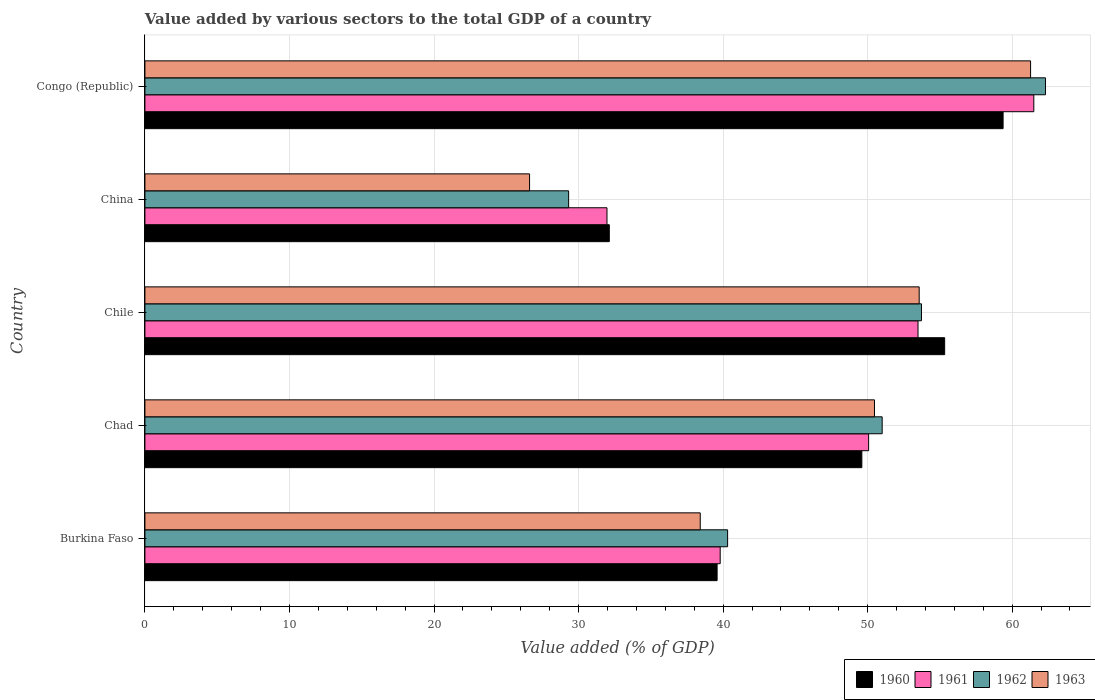How many different coloured bars are there?
Provide a short and direct response. 4. Are the number of bars per tick equal to the number of legend labels?
Give a very brief answer. Yes. Are the number of bars on each tick of the Y-axis equal?
Your answer should be very brief. Yes. What is the label of the 1st group of bars from the top?
Keep it short and to the point. Congo (Republic). In how many cases, is the number of bars for a given country not equal to the number of legend labels?
Provide a short and direct response. 0. What is the value added by various sectors to the total GDP in 1961 in Congo (Republic)?
Keep it short and to the point. 61.5. Across all countries, what is the maximum value added by various sectors to the total GDP in 1961?
Your response must be concise. 61.5. Across all countries, what is the minimum value added by various sectors to the total GDP in 1962?
Your answer should be very brief. 29.31. In which country was the value added by various sectors to the total GDP in 1963 maximum?
Your answer should be very brief. Congo (Republic). In which country was the value added by various sectors to the total GDP in 1961 minimum?
Keep it short and to the point. China. What is the total value added by various sectors to the total GDP in 1962 in the graph?
Make the answer very short. 236.66. What is the difference between the value added by various sectors to the total GDP in 1960 in China and that in Congo (Republic)?
Provide a succinct answer. -27.24. What is the difference between the value added by various sectors to the total GDP in 1960 in Chad and the value added by various sectors to the total GDP in 1961 in Congo (Republic)?
Your answer should be compact. -11.9. What is the average value added by various sectors to the total GDP in 1963 per country?
Your response must be concise. 46.07. What is the difference between the value added by various sectors to the total GDP in 1962 and value added by various sectors to the total GDP in 1960 in China?
Your answer should be compact. -2.81. What is the ratio of the value added by various sectors to the total GDP in 1962 in Chad to that in China?
Your answer should be very brief. 1.74. Is the difference between the value added by various sectors to the total GDP in 1962 in Burkina Faso and Chile greater than the difference between the value added by various sectors to the total GDP in 1960 in Burkina Faso and Chile?
Provide a succinct answer. Yes. What is the difference between the highest and the second highest value added by various sectors to the total GDP in 1961?
Ensure brevity in your answer.  8.01. What is the difference between the highest and the lowest value added by various sectors to the total GDP in 1960?
Offer a very short reply. 27.24. In how many countries, is the value added by various sectors to the total GDP in 1960 greater than the average value added by various sectors to the total GDP in 1960 taken over all countries?
Your response must be concise. 3. What does the 1st bar from the top in Burkina Faso represents?
Offer a very short reply. 1963. Is it the case that in every country, the sum of the value added by various sectors to the total GDP in 1961 and value added by various sectors to the total GDP in 1963 is greater than the value added by various sectors to the total GDP in 1960?
Ensure brevity in your answer.  Yes. Are all the bars in the graph horizontal?
Keep it short and to the point. Yes. How are the legend labels stacked?
Make the answer very short. Horizontal. What is the title of the graph?
Ensure brevity in your answer.  Value added by various sectors to the total GDP of a country. What is the label or title of the X-axis?
Your response must be concise. Value added (% of GDP). What is the label or title of the Y-axis?
Ensure brevity in your answer.  Country. What is the Value added (% of GDP) of 1960 in Burkina Faso?
Offer a very short reply. 39.59. What is the Value added (% of GDP) in 1961 in Burkina Faso?
Your answer should be compact. 39.8. What is the Value added (% of GDP) in 1962 in Burkina Faso?
Your answer should be compact. 40.31. What is the Value added (% of GDP) of 1963 in Burkina Faso?
Provide a short and direct response. 38.42. What is the Value added (% of GDP) in 1960 in Chad?
Give a very brief answer. 49.6. What is the Value added (% of GDP) of 1961 in Chad?
Make the answer very short. 50.07. What is the Value added (% of GDP) in 1962 in Chad?
Provide a short and direct response. 51.01. What is the Value added (% of GDP) in 1963 in Chad?
Offer a terse response. 50.47. What is the Value added (% of GDP) in 1960 in Chile?
Offer a very short reply. 55.33. What is the Value added (% of GDP) of 1961 in Chile?
Keep it short and to the point. 53.49. What is the Value added (% of GDP) of 1962 in Chile?
Give a very brief answer. 53.72. What is the Value added (% of GDP) in 1963 in Chile?
Provide a short and direct response. 53.57. What is the Value added (% of GDP) in 1960 in China?
Provide a succinct answer. 32.13. What is the Value added (% of GDP) of 1961 in China?
Give a very brief answer. 31.97. What is the Value added (% of GDP) of 1962 in China?
Your response must be concise. 29.31. What is the Value added (% of GDP) of 1963 in China?
Offer a terse response. 26.61. What is the Value added (% of GDP) in 1960 in Congo (Republic)?
Offer a very short reply. 59.37. What is the Value added (% of GDP) of 1961 in Congo (Republic)?
Your answer should be very brief. 61.5. What is the Value added (% of GDP) in 1962 in Congo (Republic)?
Your response must be concise. 62.3. What is the Value added (% of GDP) in 1963 in Congo (Republic)?
Keep it short and to the point. 61.27. Across all countries, what is the maximum Value added (% of GDP) of 1960?
Offer a very short reply. 59.37. Across all countries, what is the maximum Value added (% of GDP) of 1961?
Your response must be concise. 61.5. Across all countries, what is the maximum Value added (% of GDP) in 1962?
Your response must be concise. 62.3. Across all countries, what is the maximum Value added (% of GDP) of 1963?
Offer a very short reply. 61.27. Across all countries, what is the minimum Value added (% of GDP) of 1960?
Provide a succinct answer. 32.13. Across all countries, what is the minimum Value added (% of GDP) of 1961?
Your answer should be compact. 31.97. Across all countries, what is the minimum Value added (% of GDP) of 1962?
Ensure brevity in your answer.  29.31. Across all countries, what is the minimum Value added (% of GDP) in 1963?
Offer a very short reply. 26.61. What is the total Value added (% of GDP) in 1960 in the graph?
Provide a short and direct response. 236.01. What is the total Value added (% of GDP) in 1961 in the graph?
Provide a short and direct response. 236.82. What is the total Value added (% of GDP) in 1962 in the graph?
Your response must be concise. 236.66. What is the total Value added (% of GDP) of 1963 in the graph?
Ensure brevity in your answer.  230.34. What is the difference between the Value added (% of GDP) of 1960 in Burkina Faso and that in Chad?
Your answer should be compact. -10.01. What is the difference between the Value added (% of GDP) in 1961 in Burkina Faso and that in Chad?
Offer a very short reply. -10.27. What is the difference between the Value added (% of GDP) in 1962 in Burkina Faso and that in Chad?
Offer a very short reply. -10.69. What is the difference between the Value added (% of GDP) in 1963 in Burkina Faso and that in Chad?
Offer a very short reply. -12.06. What is the difference between the Value added (% of GDP) of 1960 in Burkina Faso and that in Chile?
Keep it short and to the point. -15.74. What is the difference between the Value added (% of GDP) of 1961 in Burkina Faso and that in Chile?
Ensure brevity in your answer.  -13.69. What is the difference between the Value added (% of GDP) in 1962 in Burkina Faso and that in Chile?
Offer a terse response. -13.41. What is the difference between the Value added (% of GDP) in 1963 in Burkina Faso and that in Chile?
Your answer should be very brief. -15.15. What is the difference between the Value added (% of GDP) in 1960 in Burkina Faso and that in China?
Your answer should be very brief. 7.46. What is the difference between the Value added (% of GDP) in 1961 in Burkina Faso and that in China?
Provide a short and direct response. 7.83. What is the difference between the Value added (% of GDP) in 1962 in Burkina Faso and that in China?
Your answer should be very brief. 11. What is the difference between the Value added (% of GDP) of 1963 in Burkina Faso and that in China?
Your response must be concise. 11.81. What is the difference between the Value added (% of GDP) in 1960 in Burkina Faso and that in Congo (Republic)?
Ensure brevity in your answer.  -19.79. What is the difference between the Value added (% of GDP) in 1961 in Burkina Faso and that in Congo (Republic)?
Offer a very short reply. -21.7. What is the difference between the Value added (% of GDP) in 1962 in Burkina Faso and that in Congo (Republic)?
Your answer should be compact. -21.99. What is the difference between the Value added (% of GDP) in 1963 in Burkina Faso and that in Congo (Republic)?
Give a very brief answer. -22.86. What is the difference between the Value added (% of GDP) in 1960 in Chad and that in Chile?
Your answer should be very brief. -5.73. What is the difference between the Value added (% of GDP) in 1961 in Chad and that in Chile?
Provide a short and direct response. -3.42. What is the difference between the Value added (% of GDP) in 1962 in Chad and that in Chile?
Ensure brevity in your answer.  -2.72. What is the difference between the Value added (% of GDP) of 1963 in Chad and that in Chile?
Ensure brevity in your answer.  -3.09. What is the difference between the Value added (% of GDP) in 1960 in Chad and that in China?
Your answer should be compact. 17.47. What is the difference between the Value added (% of GDP) in 1961 in Chad and that in China?
Give a very brief answer. 18.1. What is the difference between the Value added (% of GDP) in 1962 in Chad and that in China?
Offer a very short reply. 21.69. What is the difference between the Value added (% of GDP) of 1963 in Chad and that in China?
Provide a short and direct response. 23.86. What is the difference between the Value added (% of GDP) of 1960 in Chad and that in Congo (Republic)?
Provide a short and direct response. -9.77. What is the difference between the Value added (% of GDP) in 1961 in Chad and that in Congo (Republic)?
Your answer should be very brief. -11.43. What is the difference between the Value added (% of GDP) in 1962 in Chad and that in Congo (Republic)?
Make the answer very short. -11.3. What is the difference between the Value added (% of GDP) of 1963 in Chad and that in Congo (Republic)?
Ensure brevity in your answer.  -10.8. What is the difference between the Value added (% of GDP) of 1960 in Chile and that in China?
Provide a succinct answer. 23.2. What is the difference between the Value added (% of GDP) of 1961 in Chile and that in China?
Keep it short and to the point. 21.52. What is the difference between the Value added (% of GDP) of 1962 in Chile and that in China?
Ensure brevity in your answer.  24.41. What is the difference between the Value added (% of GDP) in 1963 in Chile and that in China?
Offer a terse response. 26.96. What is the difference between the Value added (% of GDP) of 1960 in Chile and that in Congo (Republic)?
Ensure brevity in your answer.  -4.04. What is the difference between the Value added (% of GDP) of 1961 in Chile and that in Congo (Republic)?
Offer a terse response. -8.01. What is the difference between the Value added (% of GDP) of 1962 in Chile and that in Congo (Republic)?
Provide a succinct answer. -8.58. What is the difference between the Value added (% of GDP) of 1963 in Chile and that in Congo (Republic)?
Offer a very short reply. -7.71. What is the difference between the Value added (% of GDP) of 1960 in China and that in Congo (Republic)?
Provide a succinct answer. -27.24. What is the difference between the Value added (% of GDP) of 1961 in China and that in Congo (Republic)?
Keep it short and to the point. -29.53. What is the difference between the Value added (% of GDP) in 1962 in China and that in Congo (Republic)?
Your answer should be very brief. -32.99. What is the difference between the Value added (% of GDP) of 1963 in China and that in Congo (Republic)?
Make the answer very short. -34.66. What is the difference between the Value added (% of GDP) in 1960 in Burkina Faso and the Value added (% of GDP) in 1961 in Chad?
Keep it short and to the point. -10.48. What is the difference between the Value added (% of GDP) in 1960 in Burkina Faso and the Value added (% of GDP) in 1962 in Chad?
Your response must be concise. -11.42. What is the difference between the Value added (% of GDP) in 1960 in Burkina Faso and the Value added (% of GDP) in 1963 in Chad?
Your answer should be compact. -10.89. What is the difference between the Value added (% of GDP) of 1961 in Burkina Faso and the Value added (% of GDP) of 1962 in Chad?
Make the answer very short. -11.21. What is the difference between the Value added (% of GDP) of 1961 in Burkina Faso and the Value added (% of GDP) of 1963 in Chad?
Your answer should be compact. -10.68. What is the difference between the Value added (% of GDP) of 1962 in Burkina Faso and the Value added (% of GDP) of 1963 in Chad?
Your answer should be very brief. -10.16. What is the difference between the Value added (% of GDP) of 1960 in Burkina Faso and the Value added (% of GDP) of 1961 in Chile?
Offer a terse response. -13.9. What is the difference between the Value added (% of GDP) in 1960 in Burkina Faso and the Value added (% of GDP) in 1962 in Chile?
Provide a short and direct response. -14.14. What is the difference between the Value added (% of GDP) in 1960 in Burkina Faso and the Value added (% of GDP) in 1963 in Chile?
Your response must be concise. -13.98. What is the difference between the Value added (% of GDP) in 1961 in Burkina Faso and the Value added (% of GDP) in 1962 in Chile?
Provide a succinct answer. -13.92. What is the difference between the Value added (% of GDP) of 1961 in Burkina Faso and the Value added (% of GDP) of 1963 in Chile?
Give a very brief answer. -13.77. What is the difference between the Value added (% of GDP) of 1962 in Burkina Faso and the Value added (% of GDP) of 1963 in Chile?
Offer a very short reply. -13.25. What is the difference between the Value added (% of GDP) of 1960 in Burkina Faso and the Value added (% of GDP) of 1961 in China?
Your answer should be compact. 7.62. What is the difference between the Value added (% of GDP) in 1960 in Burkina Faso and the Value added (% of GDP) in 1962 in China?
Provide a short and direct response. 10.27. What is the difference between the Value added (% of GDP) in 1960 in Burkina Faso and the Value added (% of GDP) in 1963 in China?
Provide a succinct answer. 12.97. What is the difference between the Value added (% of GDP) in 1961 in Burkina Faso and the Value added (% of GDP) in 1962 in China?
Your answer should be very brief. 10.49. What is the difference between the Value added (% of GDP) in 1961 in Burkina Faso and the Value added (% of GDP) in 1963 in China?
Make the answer very short. 13.19. What is the difference between the Value added (% of GDP) in 1962 in Burkina Faso and the Value added (% of GDP) in 1963 in China?
Offer a terse response. 13.7. What is the difference between the Value added (% of GDP) of 1960 in Burkina Faso and the Value added (% of GDP) of 1961 in Congo (Republic)?
Your answer should be compact. -21.91. What is the difference between the Value added (% of GDP) in 1960 in Burkina Faso and the Value added (% of GDP) in 1962 in Congo (Republic)?
Make the answer very short. -22.72. What is the difference between the Value added (% of GDP) of 1960 in Burkina Faso and the Value added (% of GDP) of 1963 in Congo (Republic)?
Provide a succinct answer. -21.69. What is the difference between the Value added (% of GDP) of 1961 in Burkina Faso and the Value added (% of GDP) of 1962 in Congo (Republic)?
Keep it short and to the point. -22.5. What is the difference between the Value added (% of GDP) of 1961 in Burkina Faso and the Value added (% of GDP) of 1963 in Congo (Republic)?
Make the answer very short. -21.47. What is the difference between the Value added (% of GDP) in 1962 in Burkina Faso and the Value added (% of GDP) in 1963 in Congo (Republic)?
Your response must be concise. -20.96. What is the difference between the Value added (% of GDP) of 1960 in Chad and the Value added (% of GDP) of 1961 in Chile?
Offer a terse response. -3.89. What is the difference between the Value added (% of GDP) of 1960 in Chad and the Value added (% of GDP) of 1962 in Chile?
Provide a succinct answer. -4.13. What is the difference between the Value added (% of GDP) in 1960 in Chad and the Value added (% of GDP) in 1963 in Chile?
Provide a succinct answer. -3.97. What is the difference between the Value added (% of GDP) of 1961 in Chad and the Value added (% of GDP) of 1962 in Chile?
Make the answer very short. -3.66. What is the difference between the Value added (% of GDP) of 1961 in Chad and the Value added (% of GDP) of 1963 in Chile?
Provide a succinct answer. -3.5. What is the difference between the Value added (% of GDP) in 1962 in Chad and the Value added (% of GDP) in 1963 in Chile?
Give a very brief answer. -2.56. What is the difference between the Value added (% of GDP) in 1960 in Chad and the Value added (% of GDP) in 1961 in China?
Give a very brief answer. 17.63. What is the difference between the Value added (% of GDP) in 1960 in Chad and the Value added (% of GDP) in 1962 in China?
Give a very brief answer. 20.29. What is the difference between the Value added (% of GDP) in 1960 in Chad and the Value added (% of GDP) in 1963 in China?
Ensure brevity in your answer.  22.99. What is the difference between the Value added (% of GDP) of 1961 in Chad and the Value added (% of GDP) of 1962 in China?
Ensure brevity in your answer.  20.76. What is the difference between the Value added (% of GDP) of 1961 in Chad and the Value added (% of GDP) of 1963 in China?
Your response must be concise. 23.46. What is the difference between the Value added (% of GDP) of 1962 in Chad and the Value added (% of GDP) of 1963 in China?
Give a very brief answer. 24.39. What is the difference between the Value added (% of GDP) of 1960 in Chad and the Value added (% of GDP) of 1961 in Congo (Republic)?
Your answer should be compact. -11.9. What is the difference between the Value added (% of GDP) in 1960 in Chad and the Value added (% of GDP) in 1962 in Congo (Republic)?
Your response must be concise. -12.7. What is the difference between the Value added (% of GDP) in 1960 in Chad and the Value added (% of GDP) in 1963 in Congo (Republic)?
Provide a succinct answer. -11.67. What is the difference between the Value added (% of GDP) of 1961 in Chad and the Value added (% of GDP) of 1962 in Congo (Republic)?
Keep it short and to the point. -12.23. What is the difference between the Value added (% of GDP) in 1961 in Chad and the Value added (% of GDP) in 1963 in Congo (Republic)?
Offer a very short reply. -11.2. What is the difference between the Value added (% of GDP) in 1962 in Chad and the Value added (% of GDP) in 1963 in Congo (Republic)?
Make the answer very short. -10.27. What is the difference between the Value added (% of GDP) of 1960 in Chile and the Value added (% of GDP) of 1961 in China?
Give a very brief answer. 23.36. What is the difference between the Value added (% of GDP) in 1960 in Chile and the Value added (% of GDP) in 1962 in China?
Offer a terse response. 26.02. What is the difference between the Value added (% of GDP) in 1960 in Chile and the Value added (% of GDP) in 1963 in China?
Offer a very short reply. 28.72. What is the difference between the Value added (% of GDP) of 1961 in Chile and the Value added (% of GDP) of 1962 in China?
Your response must be concise. 24.17. What is the difference between the Value added (% of GDP) in 1961 in Chile and the Value added (% of GDP) in 1963 in China?
Your response must be concise. 26.87. What is the difference between the Value added (% of GDP) in 1962 in Chile and the Value added (% of GDP) in 1963 in China?
Give a very brief answer. 27.11. What is the difference between the Value added (% of GDP) of 1960 in Chile and the Value added (% of GDP) of 1961 in Congo (Republic)?
Your answer should be very brief. -6.17. What is the difference between the Value added (% of GDP) of 1960 in Chile and the Value added (% of GDP) of 1962 in Congo (Republic)?
Your answer should be very brief. -6.97. What is the difference between the Value added (% of GDP) of 1960 in Chile and the Value added (% of GDP) of 1963 in Congo (Republic)?
Ensure brevity in your answer.  -5.94. What is the difference between the Value added (% of GDP) of 1961 in Chile and the Value added (% of GDP) of 1962 in Congo (Republic)?
Offer a terse response. -8.82. What is the difference between the Value added (% of GDP) of 1961 in Chile and the Value added (% of GDP) of 1963 in Congo (Republic)?
Your answer should be compact. -7.79. What is the difference between the Value added (% of GDP) of 1962 in Chile and the Value added (% of GDP) of 1963 in Congo (Republic)?
Offer a terse response. -7.55. What is the difference between the Value added (% of GDP) of 1960 in China and the Value added (% of GDP) of 1961 in Congo (Republic)?
Offer a terse response. -29.37. What is the difference between the Value added (% of GDP) in 1960 in China and the Value added (% of GDP) in 1962 in Congo (Republic)?
Keep it short and to the point. -30.18. What is the difference between the Value added (% of GDP) of 1960 in China and the Value added (% of GDP) of 1963 in Congo (Republic)?
Ensure brevity in your answer.  -29.15. What is the difference between the Value added (% of GDP) of 1961 in China and the Value added (% of GDP) of 1962 in Congo (Republic)?
Keep it short and to the point. -30.34. What is the difference between the Value added (% of GDP) of 1961 in China and the Value added (% of GDP) of 1963 in Congo (Republic)?
Your answer should be compact. -29.31. What is the difference between the Value added (% of GDP) in 1962 in China and the Value added (% of GDP) in 1963 in Congo (Republic)?
Provide a succinct answer. -31.96. What is the average Value added (% of GDP) of 1960 per country?
Provide a succinct answer. 47.2. What is the average Value added (% of GDP) of 1961 per country?
Provide a succinct answer. 47.36. What is the average Value added (% of GDP) in 1962 per country?
Offer a terse response. 47.33. What is the average Value added (% of GDP) of 1963 per country?
Give a very brief answer. 46.07. What is the difference between the Value added (% of GDP) in 1960 and Value added (% of GDP) in 1961 in Burkina Faso?
Provide a short and direct response. -0.21. What is the difference between the Value added (% of GDP) of 1960 and Value added (% of GDP) of 1962 in Burkina Faso?
Give a very brief answer. -0.73. What is the difference between the Value added (% of GDP) of 1960 and Value added (% of GDP) of 1963 in Burkina Faso?
Provide a succinct answer. 1.17. What is the difference between the Value added (% of GDP) in 1961 and Value added (% of GDP) in 1962 in Burkina Faso?
Your answer should be compact. -0.51. What is the difference between the Value added (% of GDP) in 1961 and Value added (% of GDP) in 1963 in Burkina Faso?
Make the answer very short. 1.38. What is the difference between the Value added (% of GDP) of 1962 and Value added (% of GDP) of 1963 in Burkina Faso?
Ensure brevity in your answer.  1.89. What is the difference between the Value added (% of GDP) of 1960 and Value added (% of GDP) of 1961 in Chad?
Ensure brevity in your answer.  -0.47. What is the difference between the Value added (% of GDP) in 1960 and Value added (% of GDP) in 1962 in Chad?
Your response must be concise. -1.41. What is the difference between the Value added (% of GDP) of 1960 and Value added (% of GDP) of 1963 in Chad?
Your answer should be compact. -0.88. What is the difference between the Value added (% of GDP) in 1961 and Value added (% of GDP) in 1962 in Chad?
Offer a terse response. -0.94. What is the difference between the Value added (% of GDP) of 1961 and Value added (% of GDP) of 1963 in Chad?
Ensure brevity in your answer.  -0.41. What is the difference between the Value added (% of GDP) in 1962 and Value added (% of GDP) in 1963 in Chad?
Your answer should be compact. 0.53. What is the difference between the Value added (% of GDP) of 1960 and Value added (% of GDP) of 1961 in Chile?
Your response must be concise. 1.84. What is the difference between the Value added (% of GDP) in 1960 and Value added (% of GDP) in 1962 in Chile?
Offer a very short reply. 1.6. What is the difference between the Value added (% of GDP) in 1960 and Value added (% of GDP) in 1963 in Chile?
Your answer should be very brief. 1.76. What is the difference between the Value added (% of GDP) of 1961 and Value added (% of GDP) of 1962 in Chile?
Offer a terse response. -0.24. What is the difference between the Value added (% of GDP) in 1961 and Value added (% of GDP) in 1963 in Chile?
Ensure brevity in your answer.  -0.08. What is the difference between the Value added (% of GDP) of 1962 and Value added (% of GDP) of 1963 in Chile?
Make the answer very short. 0.16. What is the difference between the Value added (% of GDP) in 1960 and Value added (% of GDP) in 1961 in China?
Your response must be concise. 0.16. What is the difference between the Value added (% of GDP) of 1960 and Value added (% of GDP) of 1962 in China?
Your answer should be very brief. 2.81. What is the difference between the Value added (% of GDP) in 1960 and Value added (% of GDP) in 1963 in China?
Offer a terse response. 5.52. What is the difference between the Value added (% of GDP) in 1961 and Value added (% of GDP) in 1962 in China?
Provide a succinct answer. 2.65. What is the difference between the Value added (% of GDP) of 1961 and Value added (% of GDP) of 1963 in China?
Provide a succinct answer. 5.36. What is the difference between the Value added (% of GDP) in 1962 and Value added (% of GDP) in 1963 in China?
Your response must be concise. 2.7. What is the difference between the Value added (% of GDP) of 1960 and Value added (% of GDP) of 1961 in Congo (Republic)?
Provide a short and direct response. -2.13. What is the difference between the Value added (% of GDP) in 1960 and Value added (% of GDP) in 1962 in Congo (Republic)?
Keep it short and to the point. -2.93. What is the difference between the Value added (% of GDP) of 1960 and Value added (% of GDP) of 1963 in Congo (Republic)?
Provide a short and direct response. -1.9. What is the difference between the Value added (% of GDP) of 1961 and Value added (% of GDP) of 1962 in Congo (Republic)?
Provide a succinct answer. -0.81. What is the difference between the Value added (% of GDP) in 1961 and Value added (% of GDP) in 1963 in Congo (Republic)?
Give a very brief answer. 0.22. What is the difference between the Value added (% of GDP) in 1962 and Value added (% of GDP) in 1963 in Congo (Republic)?
Your answer should be very brief. 1.03. What is the ratio of the Value added (% of GDP) in 1960 in Burkina Faso to that in Chad?
Offer a terse response. 0.8. What is the ratio of the Value added (% of GDP) of 1961 in Burkina Faso to that in Chad?
Your answer should be very brief. 0.79. What is the ratio of the Value added (% of GDP) of 1962 in Burkina Faso to that in Chad?
Offer a very short reply. 0.79. What is the ratio of the Value added (% of GDP) in 1963 in Burkina Faso to that in Chad?
Your answer should be compact. 0.76. What is the ratio of the Value added (% of GDP) in 1960 in Burkina Faso to that in Chile?
Your response must be concise. 0.72. What is the ratio of the Value added (% of GDP) in 1961 in Burkina Faso to that in Chile?
Provide a short and direct response. 0.74. What is the ratio of the Value added (% of GDP) of 1962 in Burkina Faso to that in Chile?
Offer a very short reply. 0.75. What is the ratio of the Value added (% of GDP) in 1963 in Burkina Faso to that in Chile?
Keep it short and to the point. 0.72. What is the ratio of the Value added (% of GDP) in 1960 in Burkina Faso to that in China?
Keep it short and to the point. 1.23. What is the ratio of the Value added (% of GDP) of 1961 in Burkina Faso to that in China?
Your answer should be compact. 1.25. What is the ratio of the Value added (% of GDP) in 1962 in Burkina Faso to that in China?
Offer a very short reply. 1.38. What is the ratio of the Value added (% of GDP) of 1963 in Burkina Faso to that in China?
Offer a very short reply. 1.44. What is the ratio of the Value added (% of GDP) of 1960 in Burkina Faso to that in Congo (Republic)?
Give a very brief answer. 0.67. What is the ratio of the Value added (% of GDP) of 1961 in Burkina Faso to that in Congo (Republic)?
Your answer should be compact. 0.65. What is the ratio of the Value added (% of GDP) in 1962 in Burkina Faso to that in Congo (Republic)?
Your answer should be compact. 0.65. What is the ratio of the Value added (% of GDP) of 1963 in Burkina Faso to that in Congo (Republic)?
Your answer should be very brief. 0.63. What is the ratio of the Value added (% of GDP) in 1960 in Chad to that in Chile?
Your response must be concise. 0.9. What is the ratio of the Value added (% of GDP) of 1961 in Chad to that in Chile?
Keep it short and to the point. 0.94. What is the ratio of the Value added (% of GDP) of 1962 in Chad to that in Chile?
Provide a succinct answer. 0.95. What is the ratio of the Value added (% of GDP) of 1963 in Chad to that in Chile?
Provide a succinct answer. 0.94. What is the ratio of the Value added (% of GDP) of 1960 in Chad to that in China?
Keep it short and to the point. 1.54. What is the ratio of the Value added (% of GDP) in 1961 in Chad to that in China?
Provide a succinct answer. 1.57. What is the ratio of the Value added (% of GDP) of 1962 in Chad to that in China?
Give a very brief answer. 1.74. What is the ratio of the Value added (% of GDP) in 1963 in Chad to that in China?
Provide a short and direct response. 1.9. What is the ratio of the Value added (% of GDP) in 1960 in Chad to that in Congo (Republic)?
Provide a succinct answer. 0.84. What is the ratio of the Value added (% of GDP) in 1961 in Chad to that in Congo (Republic)?
Make the answer very short. 0.81. What is the ratio of the Value added (% of GDP) of 1962 in Chad to that in Congo (Republic)?
Make the answer very short. 0.82. What is the ratio of the Value added (% of GDP) of 1963 in Chad to that in Congo (Republic)?
Offer a very short reply. 0.82. What is the ratio of the Value added (% of GDP) of 1960 in Chile to that in China?
Your response must be concise. 1.72. What is the ratio of the Value added (% of GDP) of 1961 in Chile to that in China?
Provide a short and direct response. 1.67. What is the ratio of the Value added (% of GDP) in 1962 in Chile to that in China?
Give a very brief answer. 1.83. What is the ratio of the Value added (% of GDP) of 1963 in Chile to that in China?
Make the answer very short. 2.01. What is the ratio of the Value added (% of GDP) in 1960 in Chile to that in Congo (Republic)?
Make the answer very short. 0.93. What is the ratio of the Value added (% of GDP) of 1961 in Chile to that in Congo (Republic)?
Your response must be concise. 0.87. What is the ratio of the Value added (% of GDP) in 1962 in Chile to that in Congo (Republic)?
Provide a short and direct response. 0.86. What is the ratio of the Value added (% of GDP) in 1963 in Chile to that in Congo (Republic)?
Your answer should be compact. 0.87. What is the ratio of the Value added (% of GDP) in 1960 in China to that in Congo (Republic)?
Your answer should be very brief. 0.54. What is the ratio of the Value added (% of GDP) of 1961 in China to that in Congo (Republic)?
Offer a very short reply. 0.52. What is the ratio of the Value added (% of GDP) in 1962 in China to that in Congo (Republic)?
Your response must be concise. 0.47. What is the ratio of the Value added (% of GDP) of 1963 in China to that in Congo (Republic)?
Offer a terse response. 0.43. What is the difference between the highest and the second highest Value added (% of GDP) of 1960?
Make the answer very short. 4.04. What is the difference between the highest and the second highest Value added (% of GDP) of 1961?
Your response must be concise. 8.01. What is the difference between the highest and the second highest Value added (% of GDP) of 1962?
Your answer should be compact. 8.58. What is the difference between the highest and the second highest Value added (% of GDP) in 1963?
Keep it short and to the point. 7.71. What is the difference between the highest and the lowest Value added (% of GDP) in 1960?
Your answer should be compact. 27.24. What is the difference between the highest and the lowest Value added (% of GDP) of 1961?
Ensure brevity in your answer.  29.53. What is the difference between the highest and the lowest Value added (% of GDP) in 1962?
Your answer should be very brief. 32.99. What is the difference between the highest and the lowest Value added (% of GDP) of 1963?
Offer a terse response. 34.66. 